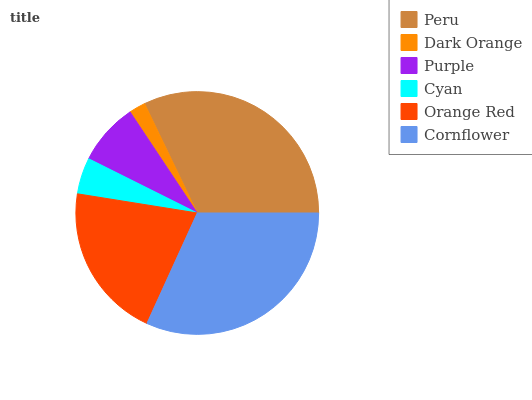Is Dark Orange the minimum?
Answer yes or no. Yes. Is Peru the maximum?
Answer yes or no. Yes. Is Purple the minimum?
Answer yes or no. No. Is Purple the maximum?
Answer yes or no. No. Is Purple greater than Dark Orange?
Answer yes or no. Yes. Is Dark Orange less than Purple?
Answer yes or no. Yes. Is Dark Orange greater than Purple?
Answer yes or no. No. Is Purple less than Dark Orange?
Answer yes or no. No. Is Orange Red the high median?
Answer yes or no. Yes. Is Purple the low median?
Answer yes or no. Yes. Is Dark Orange the high median?
Answer yes or no. No. Is Cyan the low median?
Answer yes or no. No. 